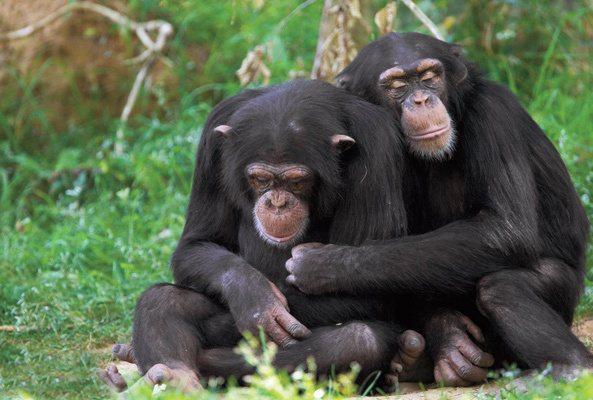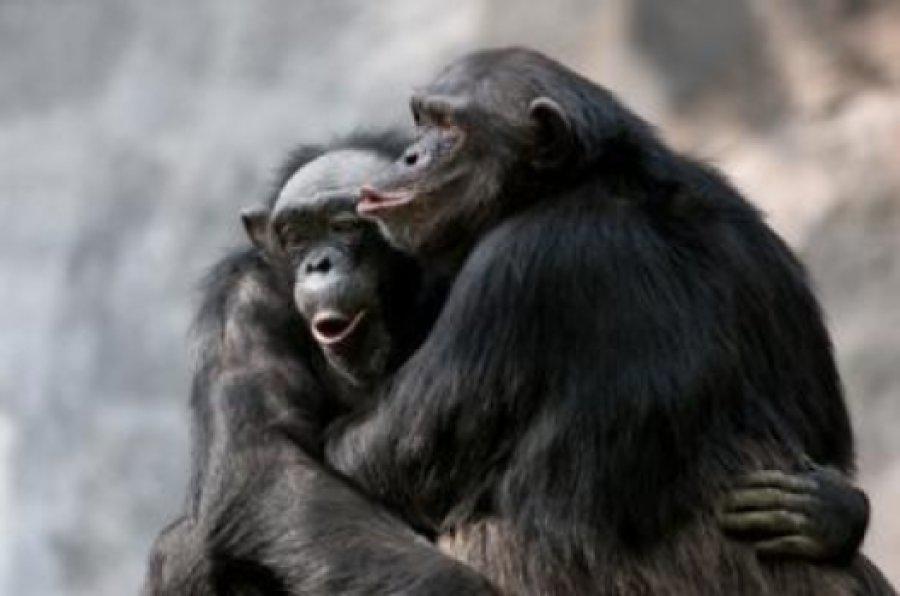The first image is the image on the left, the second image is the image on the right. Considering the images on both sides, is "chimps are hugging each other in both image pairs" valid? Answer yes or no. Yes. The first image is the image on the left, the second image is the image on the right. Assess this claim about the two images: "The apes are hugging each other in both pictures.". Correct or not? Answer yes or no. Yes. 